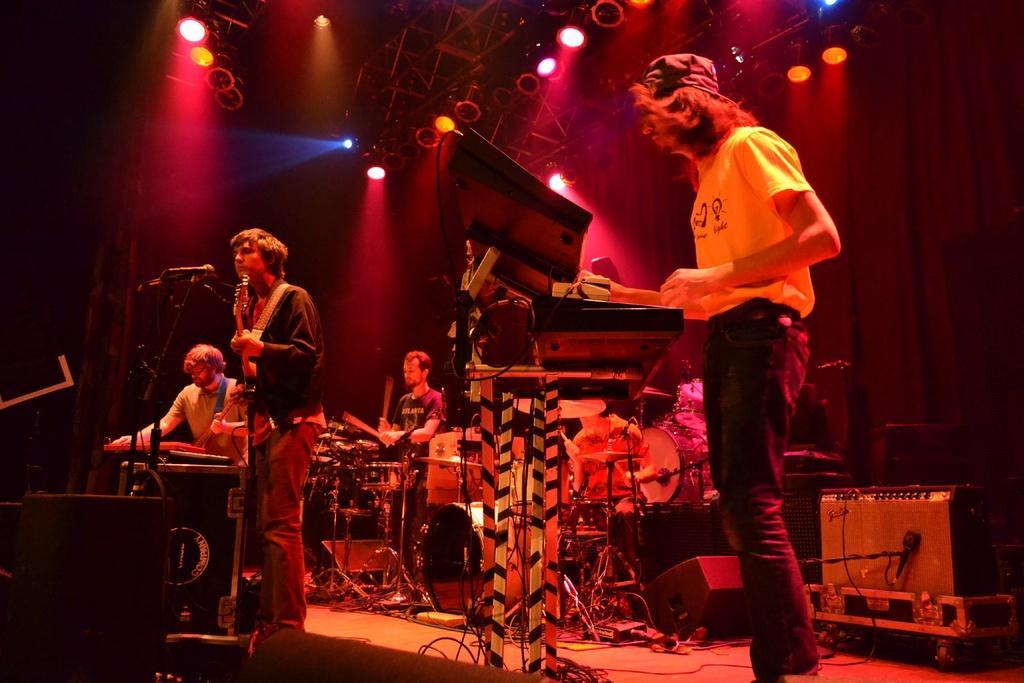Please provide a concise description of this image. In this picture there are few musicians on the floor. The man to the right corner is playing keyboard. The man at the center is playing guitar. The man beside him is playing keyboard. The man behind them is playing drums. There are microphones in front of them. In the background there is curtain and spotlights. On the floor there are mics, speakers, boxes and cables. 